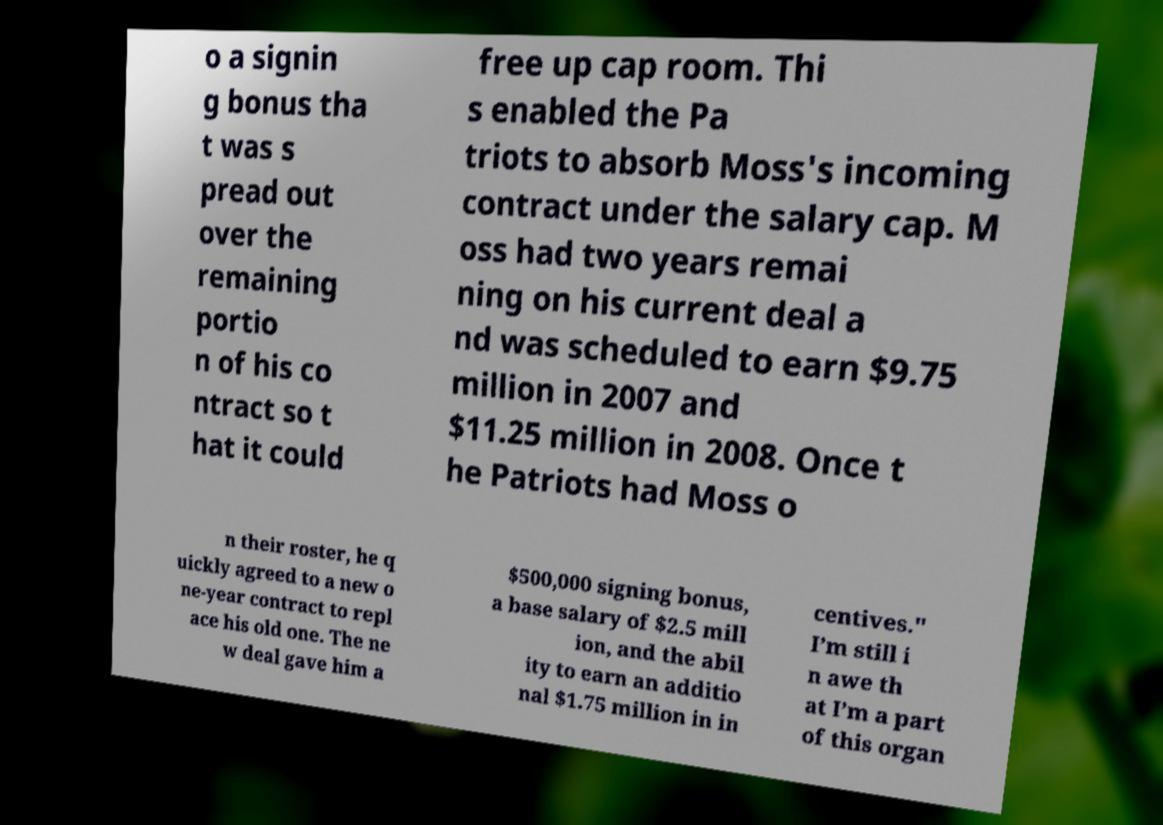What messages or text are displayed in this image? I need them in a readable, typed format. o a signin g bonus tha t was s pread out over the remaining portio n of his co ntract so t hat it could free up cap room. Thi s enabled the Pa triots to absorb Moss's incoming contract under the salary cap. M oss had two years remai ning on his current deal a nd was scheduled to earn $9.75 million in 2007 and $11.25 million in 2008. Once t he Patriots had Moss o n their roster, he q uickly agreed to a new o ne-year contract to repl ace his old one. The ne w deal gave him a $500,000 signing bonus, a base salary of $2.5 mill ion, and the abil ity to earn an additio nal $1.75 million in in centives." I’m still i n awe th at I’m a part of this organ 